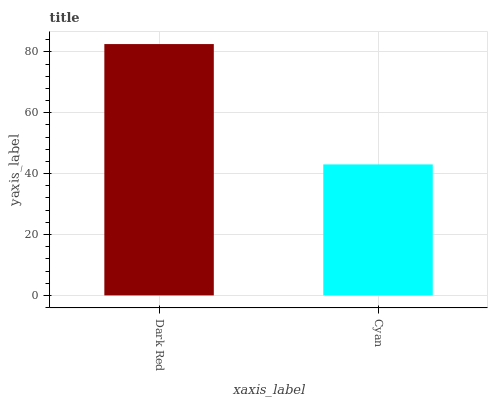Is Cyan the minimum?
Answer yes or no. Yes. Is Dark Red the maximum?
Answer yes or no. Yes. Is Cyan the maximum?
Answer yes or no. No. Is Dark Red greater than Cyan?
Answer yes or no. Yes. Is Cyan less than Dark Red?
Answer yes or no. Yes. Is Cyan greater than Dark Red?
Answer yes or no. No. Is Dark Red less than Cyan?
Answer yes or no. No. Is Dark Red the high median?
Answer yes or no. Yes. Is Cyan the low median?
Answer yes or no. Yes. Is Cyan the high median?
Answer yes or no. No. Is Dark Red the low median?
Answer yes or no. No. 